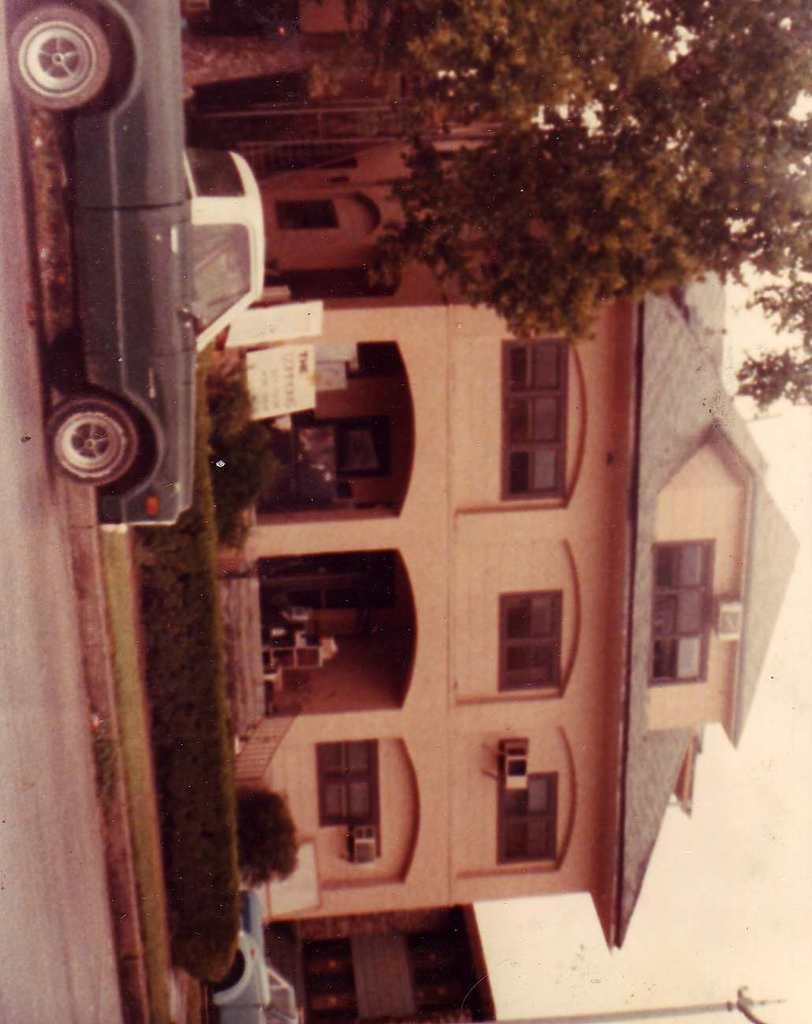What is the orientation of the image? The image is vertical. What can be seen in the background of the image? There is a building in the background of the image. What is located in front of the building? There are plants and trees in front of the building. What is happening on the road in the image? There are cars moving on the road in the image. What part of the natural environment is visible in the image? The sky is visible in the image. What type of feather can be seen falling from the sky in the image? There is no feather falling from the sky in the image; only cars, buildings, plants, trees, and the sky are visible. What type of cloth is draped over the building in the image? There is no cloth draped over the building in the image; only the building, plants, trees, and cars are visible. 